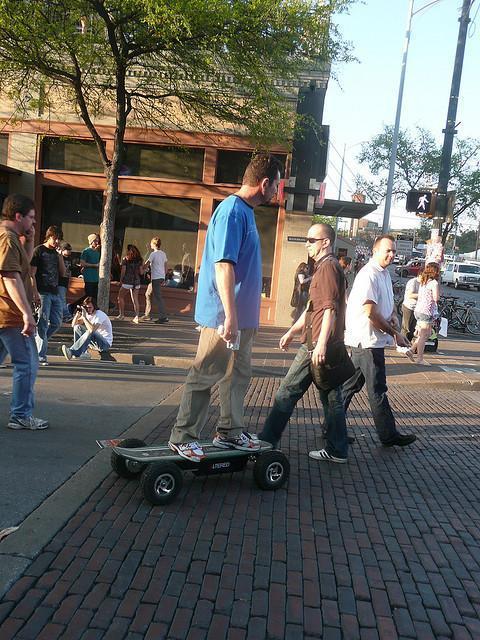How many people are there?
Give a very brief answer. 5. 